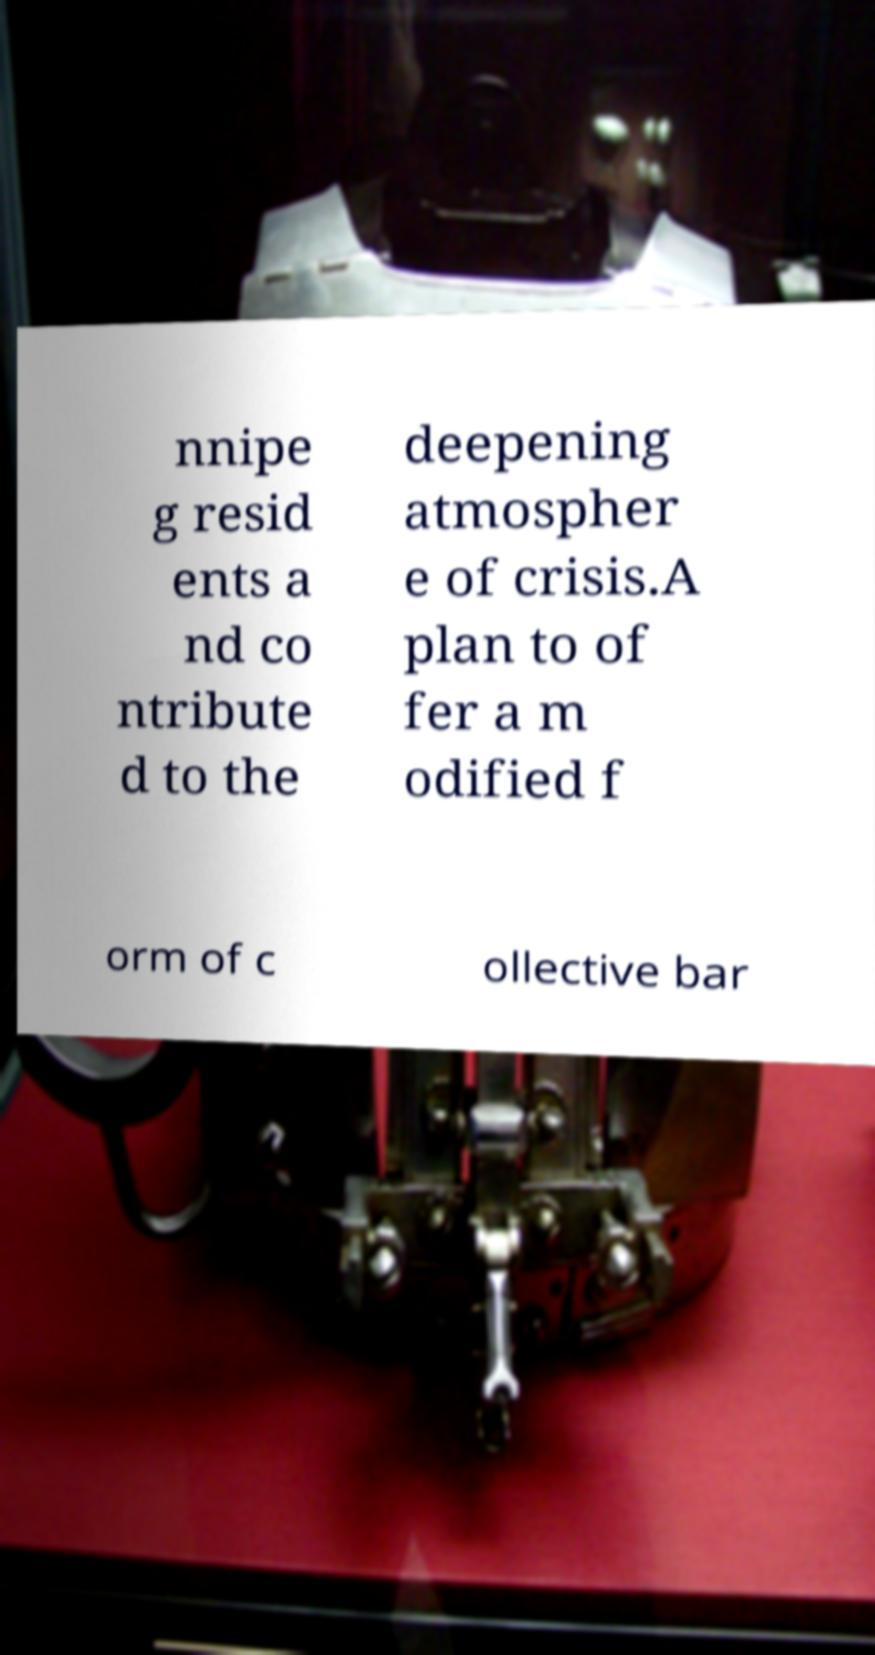Could you assist in decoding the text presented in this image and type it out clearly? nnipe g resid ents a nd co ntribute d to the deepening atmospher e of crisis.A plan to of fer a m odified f orm of c ollective bar 